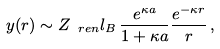Convert formula to latex. <formula><loc_0><loc_0><loc_500><loc_500>y ( r ) \sim Z _ { \ r e n } l _ { B } \, \frac { e ^ { \kappa a } } { 1 + \kappa a } \frac { e ^ { - \kappa r } } { r } \, ,</formula> 